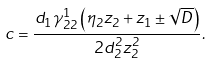Convert formula to latex. <formula><loc_0><loc_0><loc_500><loc_500>c = \frac { d _ { 1 } \gamma _ { 2 2 } ^ { 1 } \left ( \eta _ { 2 } z _ { 2 } + z _ { 1 } \pm \sqrt { D } \right ) } { 2 d _ { 2 } ^ { 2 } z _ { 2 } ^ { 2 } } .</formula> 